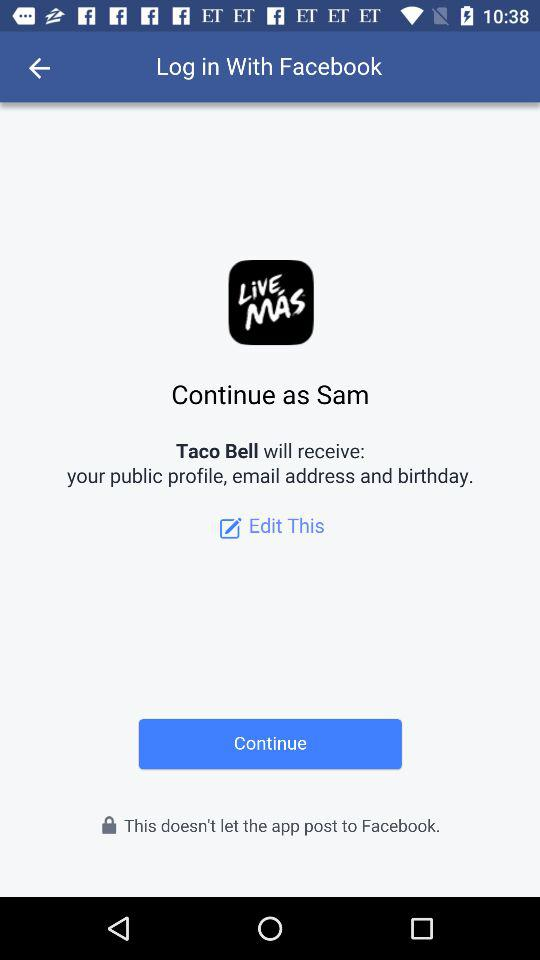What is the login name? The login name is Sam. 